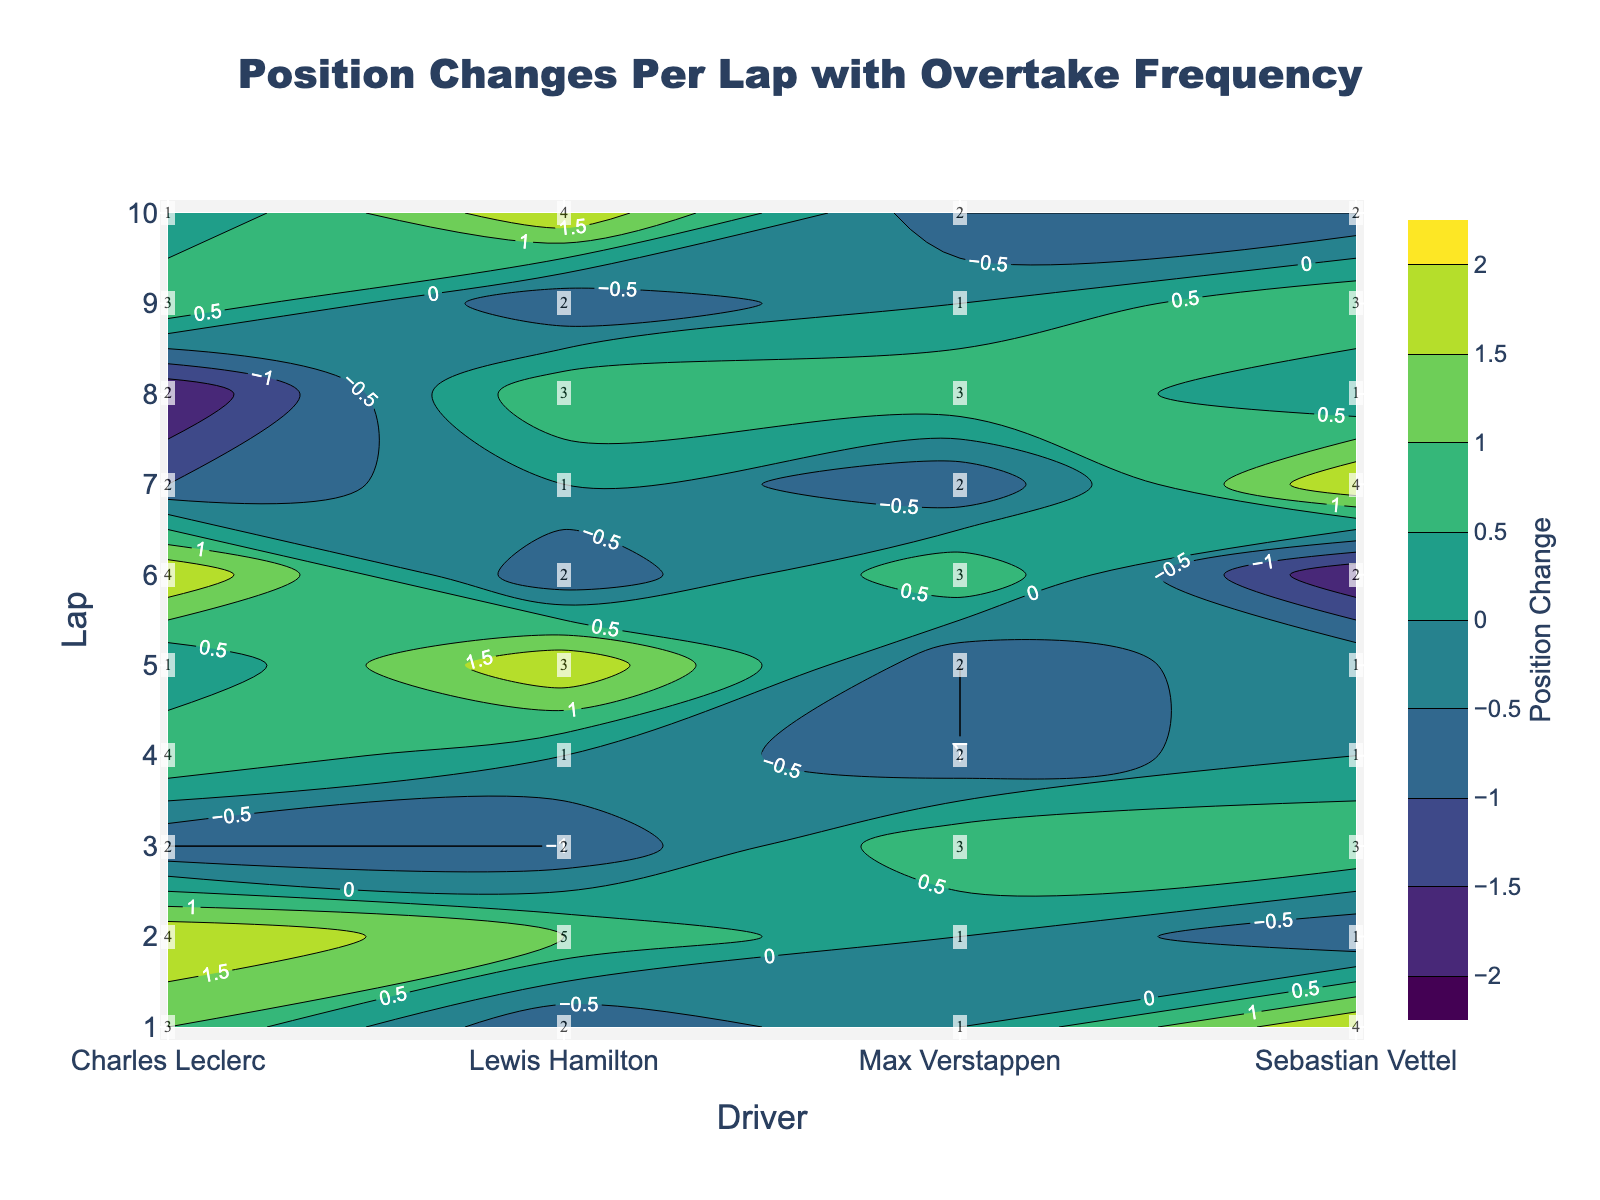What's the title of the figure? The title is located at the top center of the figure, and it reads "Position Changes Per Lap with Overtake Frequency"
Answer: Position Changes Per Lap with Overtake Frequency Which driver had the highest number of position changes on Lap 5? On Lap 5, the contour plot shows numbers in cells, and for Lewis Hamilton, the position change is 2 which is the highest number among drivers on this lap
Answer: Lewis Hamilton Which lap had the maximum overtake frequency for Charles Leclerc? The lap with the highest number annotated in the cell corresponding to Charles Leclerc is Lap 4, where the annotation shows an overtake frequency of 4
Answer: Lap 4 Does Max Verstappen ever have a position change of 1? If so, which laps? By observing the contour levels with value 1 and locating Max Verstappen, it is evident that he has position changes of 1 on Laps 3, 6, and 8
Answer: Laps 3, 6, and 8 How does the position change pattern differ between Lewis Hamilton and Sebastian Vettel? Lewis Hamilton’s position changes fluctuate, showing both increases and decreases, while Sebastian Vettel also has fluctuating changes, but overall patterns can be compared throughout the laps by observing contour levels and color intensity
Answer: Both drivers have fluctuating changes Which driver shows the most consistent position change trend? By observing consistency in color and contour levels, Max Verstappen shows many zeroes indicating consistent position changes compared to others
Answer: Max Verstappen What is the average overtake frequency for Max Verstappen across all laps? Summing the overtake frequencies for Max Verstappen: 1+1+3+2+2+3+2+3+1+2 = 20 and dividing by 10 laps gives the average as 20/10
Answer: 2 How many times does Lewis Hamilton’s position change decrease by 1? By counting contours labeled -1 in Lewis Hamilton's column, it happens on Laps 1, 3, 6, and 9
Answer: 4 times If you sum all the overtakes in Lap 7, what is the total? Adding all the annotated overtake frequencies for Lap 7: 1+2+2+4 = 9
Answer: 9 Which driver had the highest single overtake frequency, and in which lap did it occur? The contour plot annotations show the highest overtake frequency as 5 for Lewis Hamilton in Lap 2
Answer: Lewis Hamilton in Lap 2 